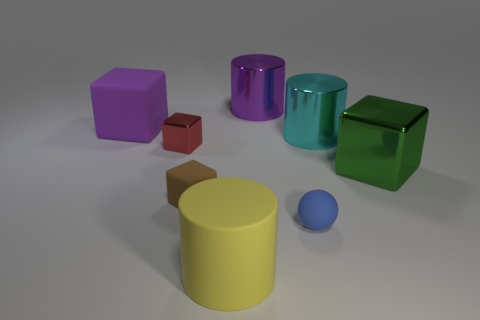Subtract all metal cylinders. How many cylinders are left? 1 Subtract all red blocks. How many blocks are left? 3 Subtract 2 blocks. How many blocks are left? 2 Subtract all cylinders. How many objects are left? 5 Add 1 red objects. How many objects exist? 9 Subtract all purple balls. How many red blocks are left? 1 Subtract all big purple matte things. Subtract all red blocks. How many objects are left? 6 Add 8 tiny metallic cubes. How many tiny metallic cubes are left? 9 Add 3 gray shiny objects. How many gray shiny objects exist? 3 Subtract 1 purple blocks. How many objects are left? 7 